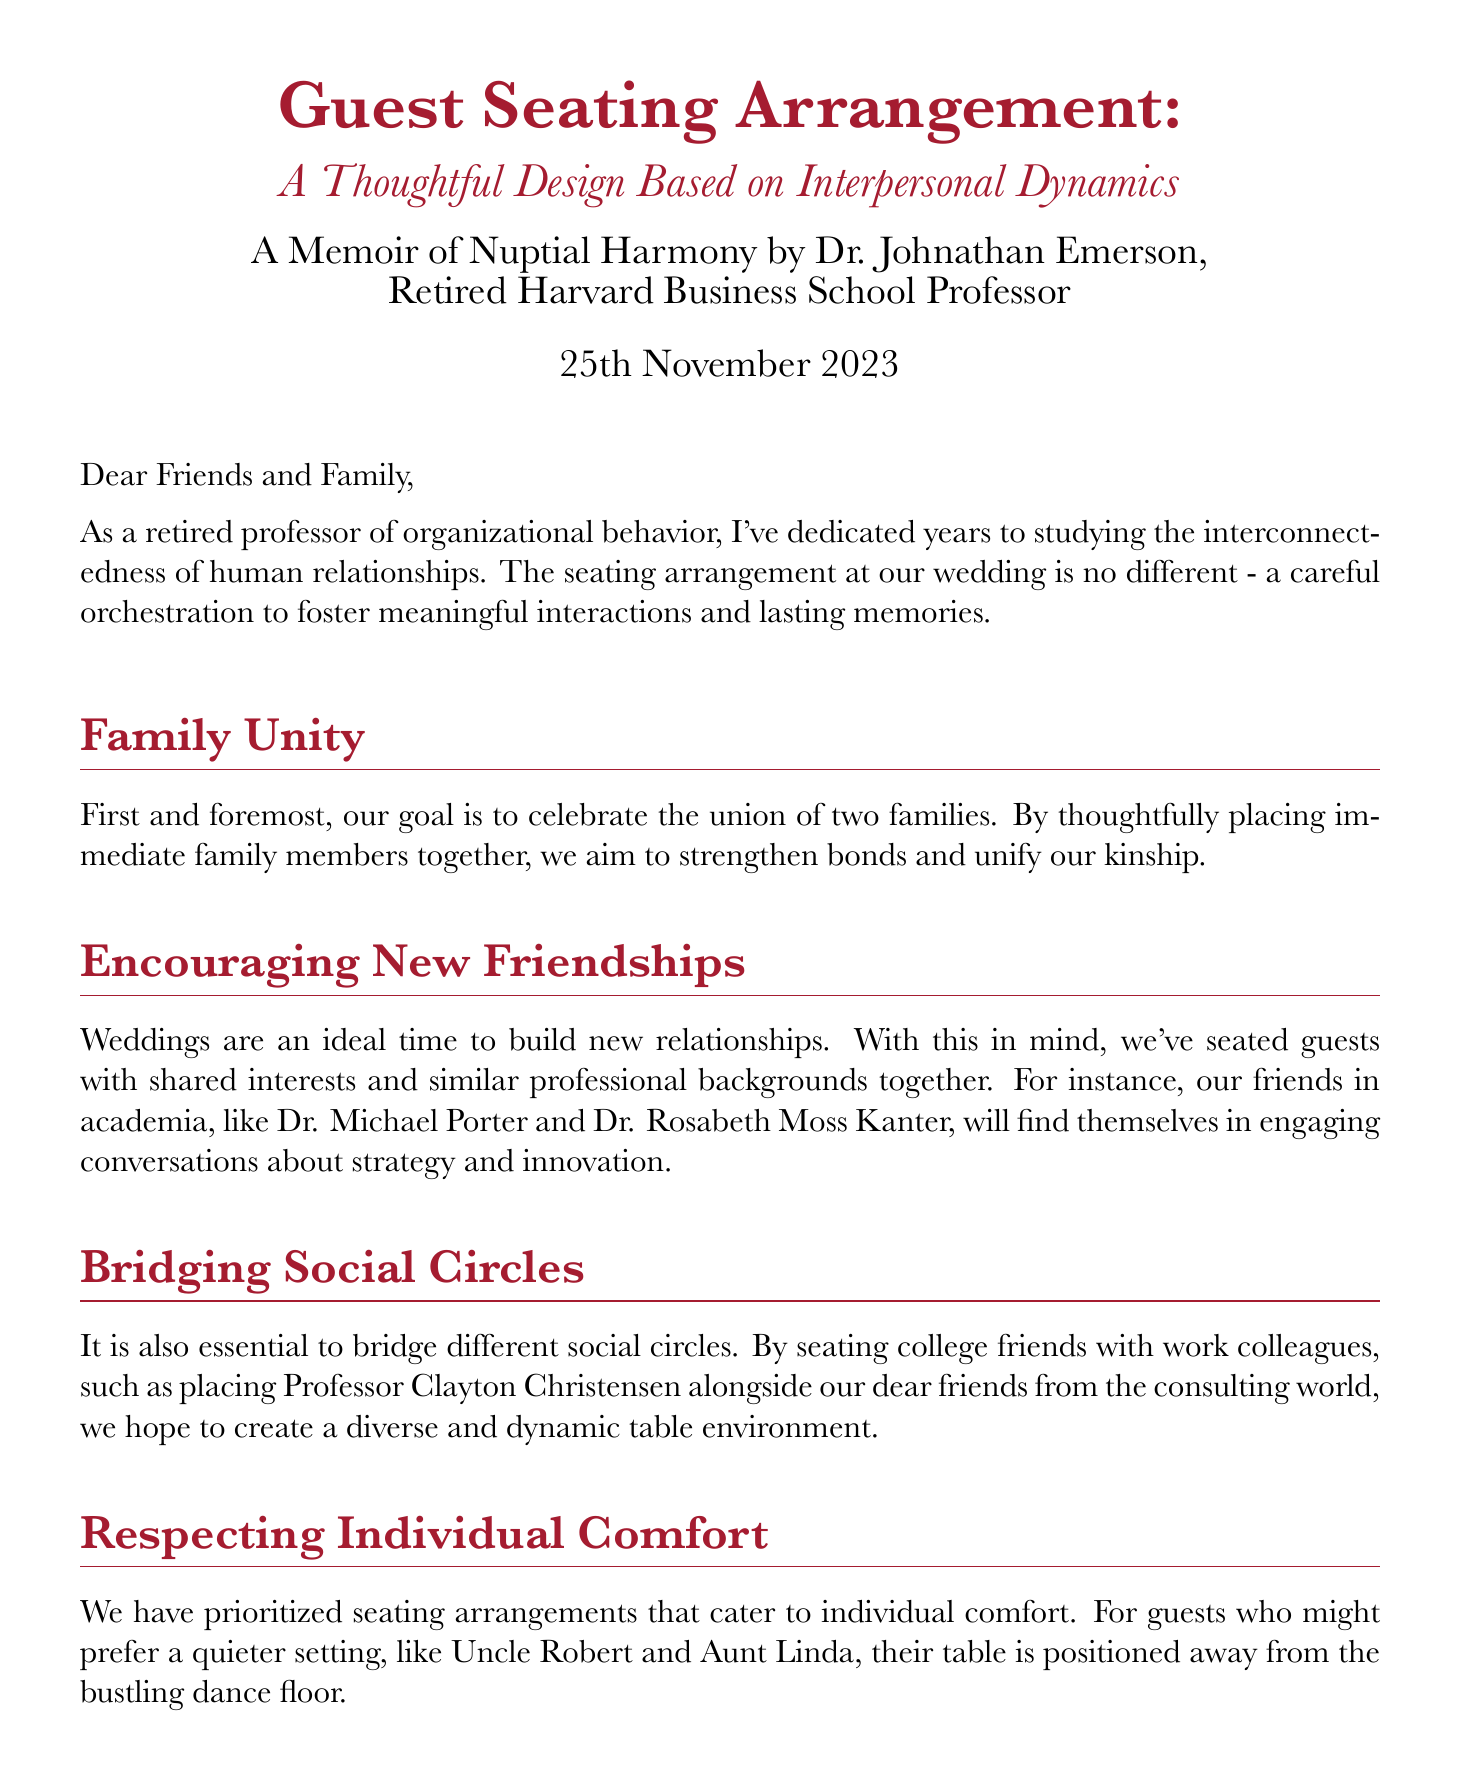What is the date of the wedding? The date of the wedding is clearly stated in the document as "25th November 2023."
Answer: 25th November 2023 Who is the author of the seating arrangement memoir? The document mentions that Dr. Johnathan Emerson is the author, indicated in the signature.
Answer: Dr. Johnathan Emerson What is the primary goal of the seating arrangement? The document states that the primary goal is to "celebrate the union of two families."
Answer: Celebrate the union of two families Which guests are placed together to foster engaging conversations? The document references placing "Dr. Michael Porter and Dr. Rosabeth Moss Kanter" together for conversations.
Answer: Dr. Michael Porter and Dr. Rosabeth Moss Kanter What consideration is made for elderly guests? The document highlights that special attention is given to "Grandmother Eleanor's table" near the restrooms for elderly guests.
Answer: Grandmother Eleanor's table What type of setting is provided for Uncle Robert and Aunt Linda? The arrangement for Uncle Robert and Aunt Linda is described as positioned "away from the bustling dance floor."
Answer: Away from the bustling dance floor What is emphasized as the essence of the union in the seating arrangement? The document emphasizes that the essence of the union is characterized by "love, respect, and harmony."
Answer: Love, respect, and harmony How does the author describe the seating arrangement process? The author describes the process as a "careful orchestration" to foster meaningful interactions.
Answer: Careful orchestration What theme is prevalent in the seating arrangements discussed? The document prominently discusses the theme of "interpersonal dynamics."
Answer: Interpersonal dynamics 